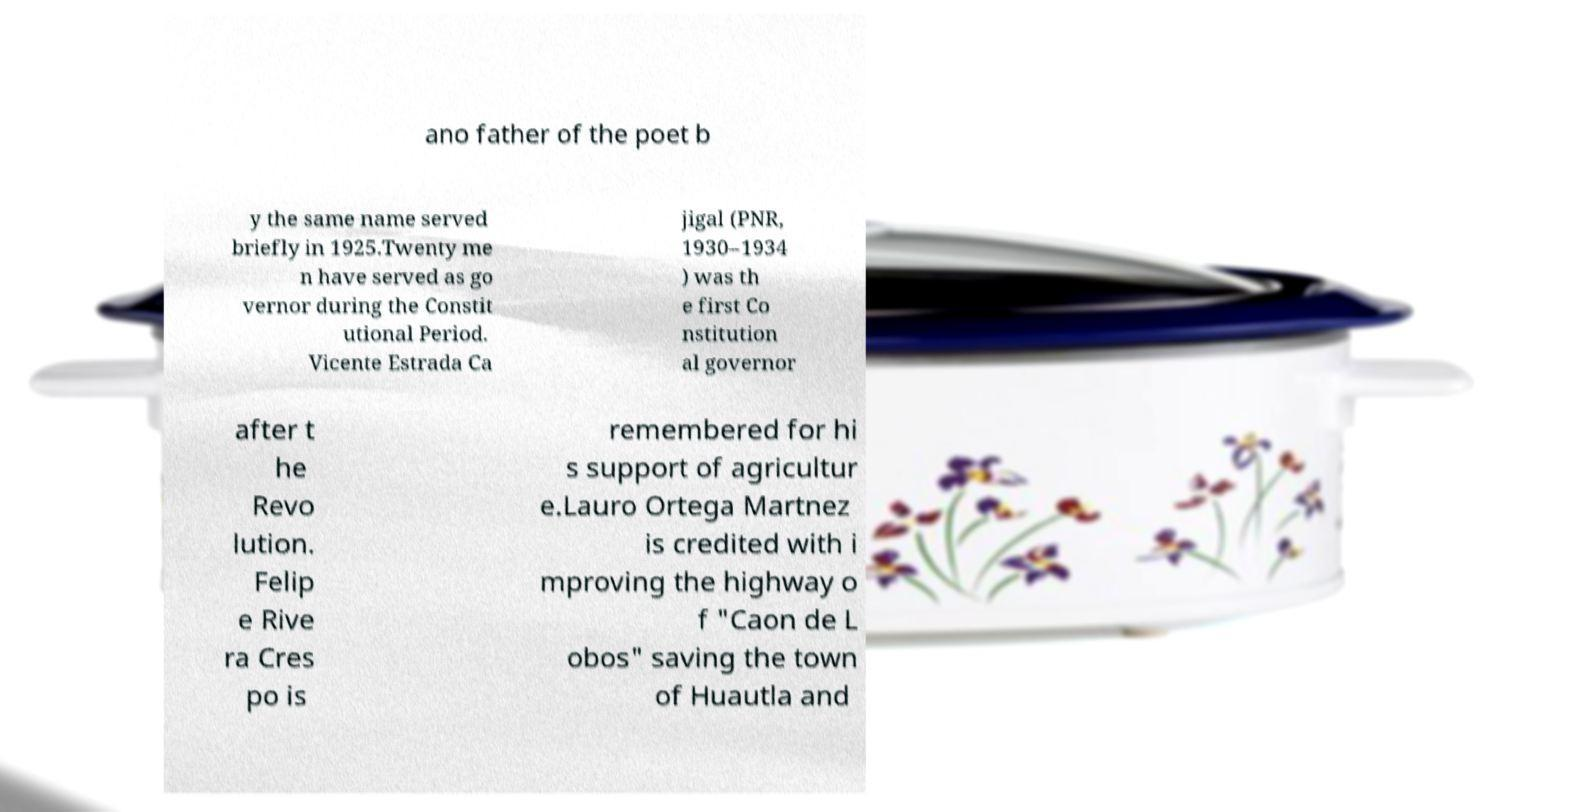Could you assist in decoding the text presented in this image and type it out clearly? ano father of the poet b y the same name served briefly in 1925.Twenty me n have served as go vernor during the Constit utional Period. Vicente Estrada Ca jigal (PNR, 1930–1934 ) was th e first Co nstitution al governor after t he Revo lution. Felip e Rive ra Cres po is remembered for hi s support of agricultur e.Lauro Ortega Martnez is credited with i mproving the highway o f "Caon de L obos" saving the town of Huautla and 